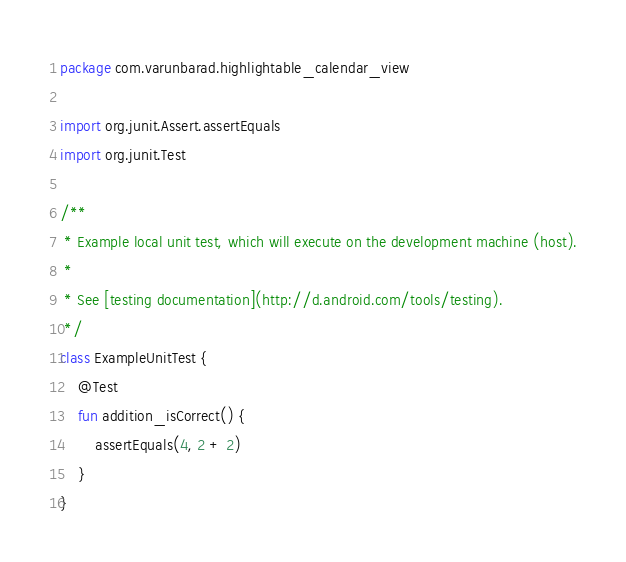Convert code to text. <code><loc_0><loc_0><loc_500><loc_500><_Kotlin_>package com.varunbarad.highlightable_calendar_view

import org.junit.Assert.assertEquals
import org.junit.Test

/**
 * Example local unit test, which will execute on the development machine (host).
 *
 * See [testing documentation](http://d.android.com/tools/testing).
 */
class ExampleUnitTest {
    @Test
    fun addition_isCorrect() {
        assertEquals(4, 2 + 2)
    }
}
</code> 